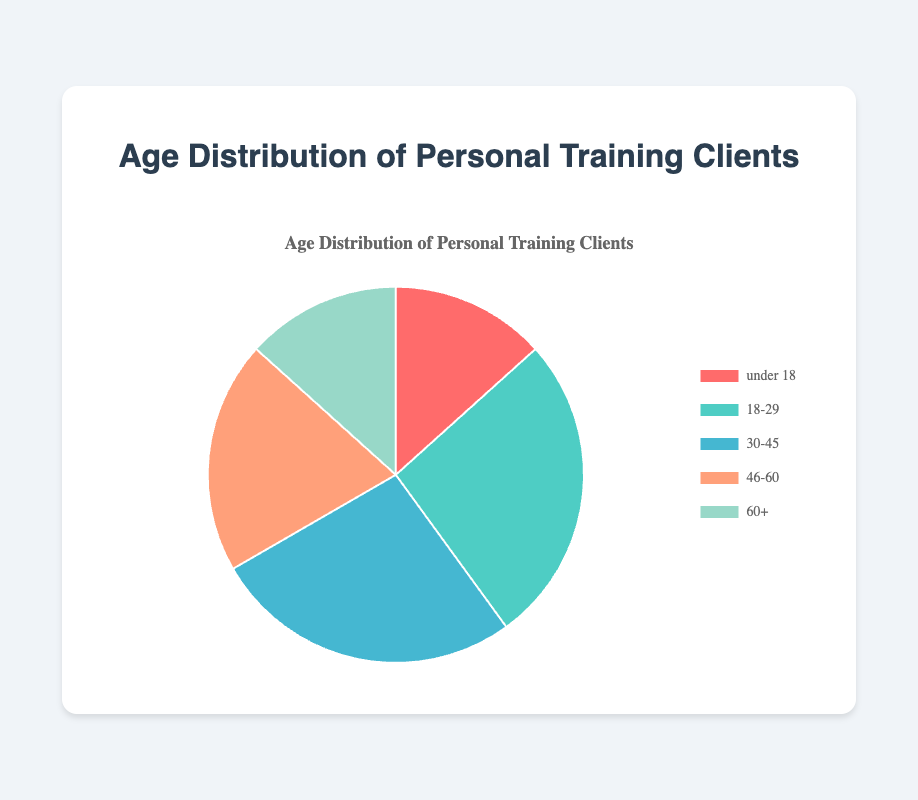What is the proportion of clients in the age group 18-29? To find the proportion of clients in the 18-29 age group, we count the number of clients in that group and divide it by the total number of clients. There are 5 clients in the 18-29 group and 15 clients in total, so the proportion is 5/15.
Answer: 1/3 or about 33.3% Which age group has the fewest clients? By visually inspecting the pie chart, we identify the slice with the smallest area or count the number of clients in each group. The 'under 18' age group has the smallest number of clients, with only 2.
Answer: under 18 Compare the number of clients in the '46-60' age group and the '60+' age group. Which group has more clients? From the pie chart, we note the count of clients in each age group: 3 in '46-60' and 2 in '60+'. Hence, the '46-60' age group has more clients.
Answer: 46-60 What percentage of the clients are 60 years or older? To find the percentage, we divide the number of clients in the '60+' group by the total number of clients and multiply by 100. There are 2 clients in the '60+' group out of 15 total clients. The calculation is (2/15) * 100.
Answer: About 13.3% How many more clients are there in the '30-45' age group compared to the 'under 18' age group? The '30-45' age group has 4 clients and the 'under 18' age group has 2 clients. The difference is 4 - 2.
Answer: 2 Which age groups have an equal number of clients? By visually comparing the sizes of the slices and correlating with the counts, we see that '30-45' and '46-60' both have 3 clients each.
Answer: 30-45 and 46-60 If you sum the clients from the groups 'under 18' and '60+', how many clients would that be in total? Adding the number of clients in 'under 18' which is 2, and in '60+' which is 2, the total is 2 + 2.
Answer: 4 What is the ratio of clients in the '18-29' age group to those in the '30-45' age group? There are 5 clients in the '18-29' age group and 4 clients in the '30-45' age group. The ratio is 5 to 4.
Answer: 5:4 Identify the age group represented by the green segment of the pie chart. By associating the color with the labeled sections, the green segment corresponds to the '30-45' age group.
Answer: 30-45 